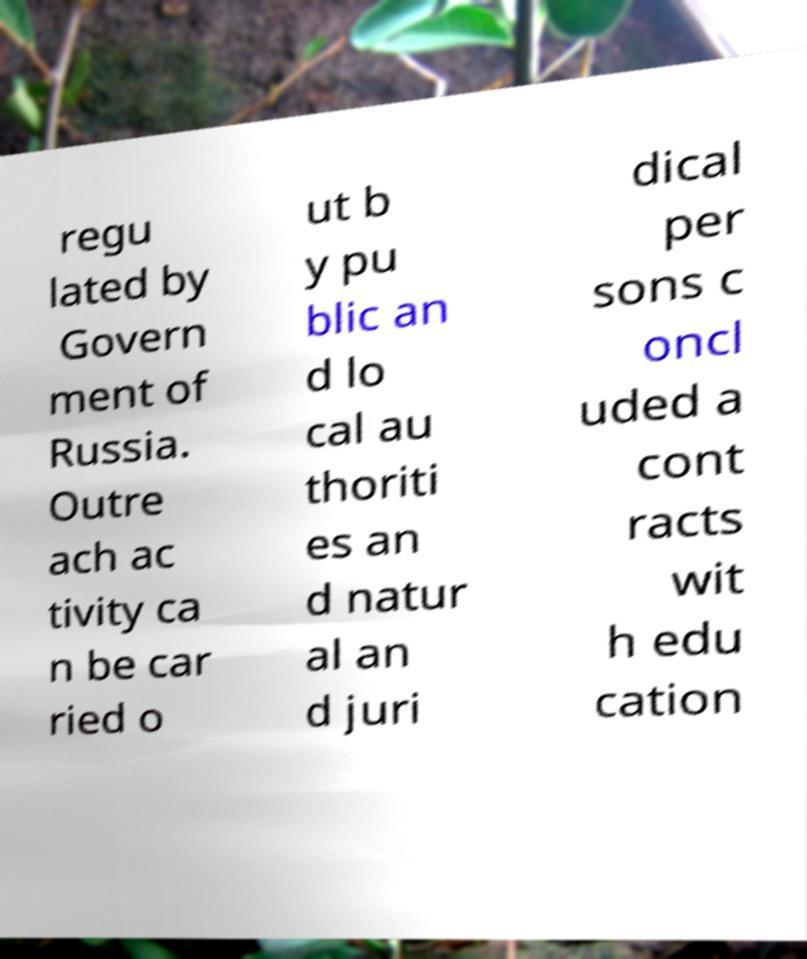What messages or text are displayed in this image? I need them in a readable, typed format. regu lated by Govern ment of Russia. Outre ach ac tivity ca n be car ried o ut b y pu blic an d lo cal au thoriti es an d natur al an d juri dical per sons c oncl uded a cont racts wit h edu cation 